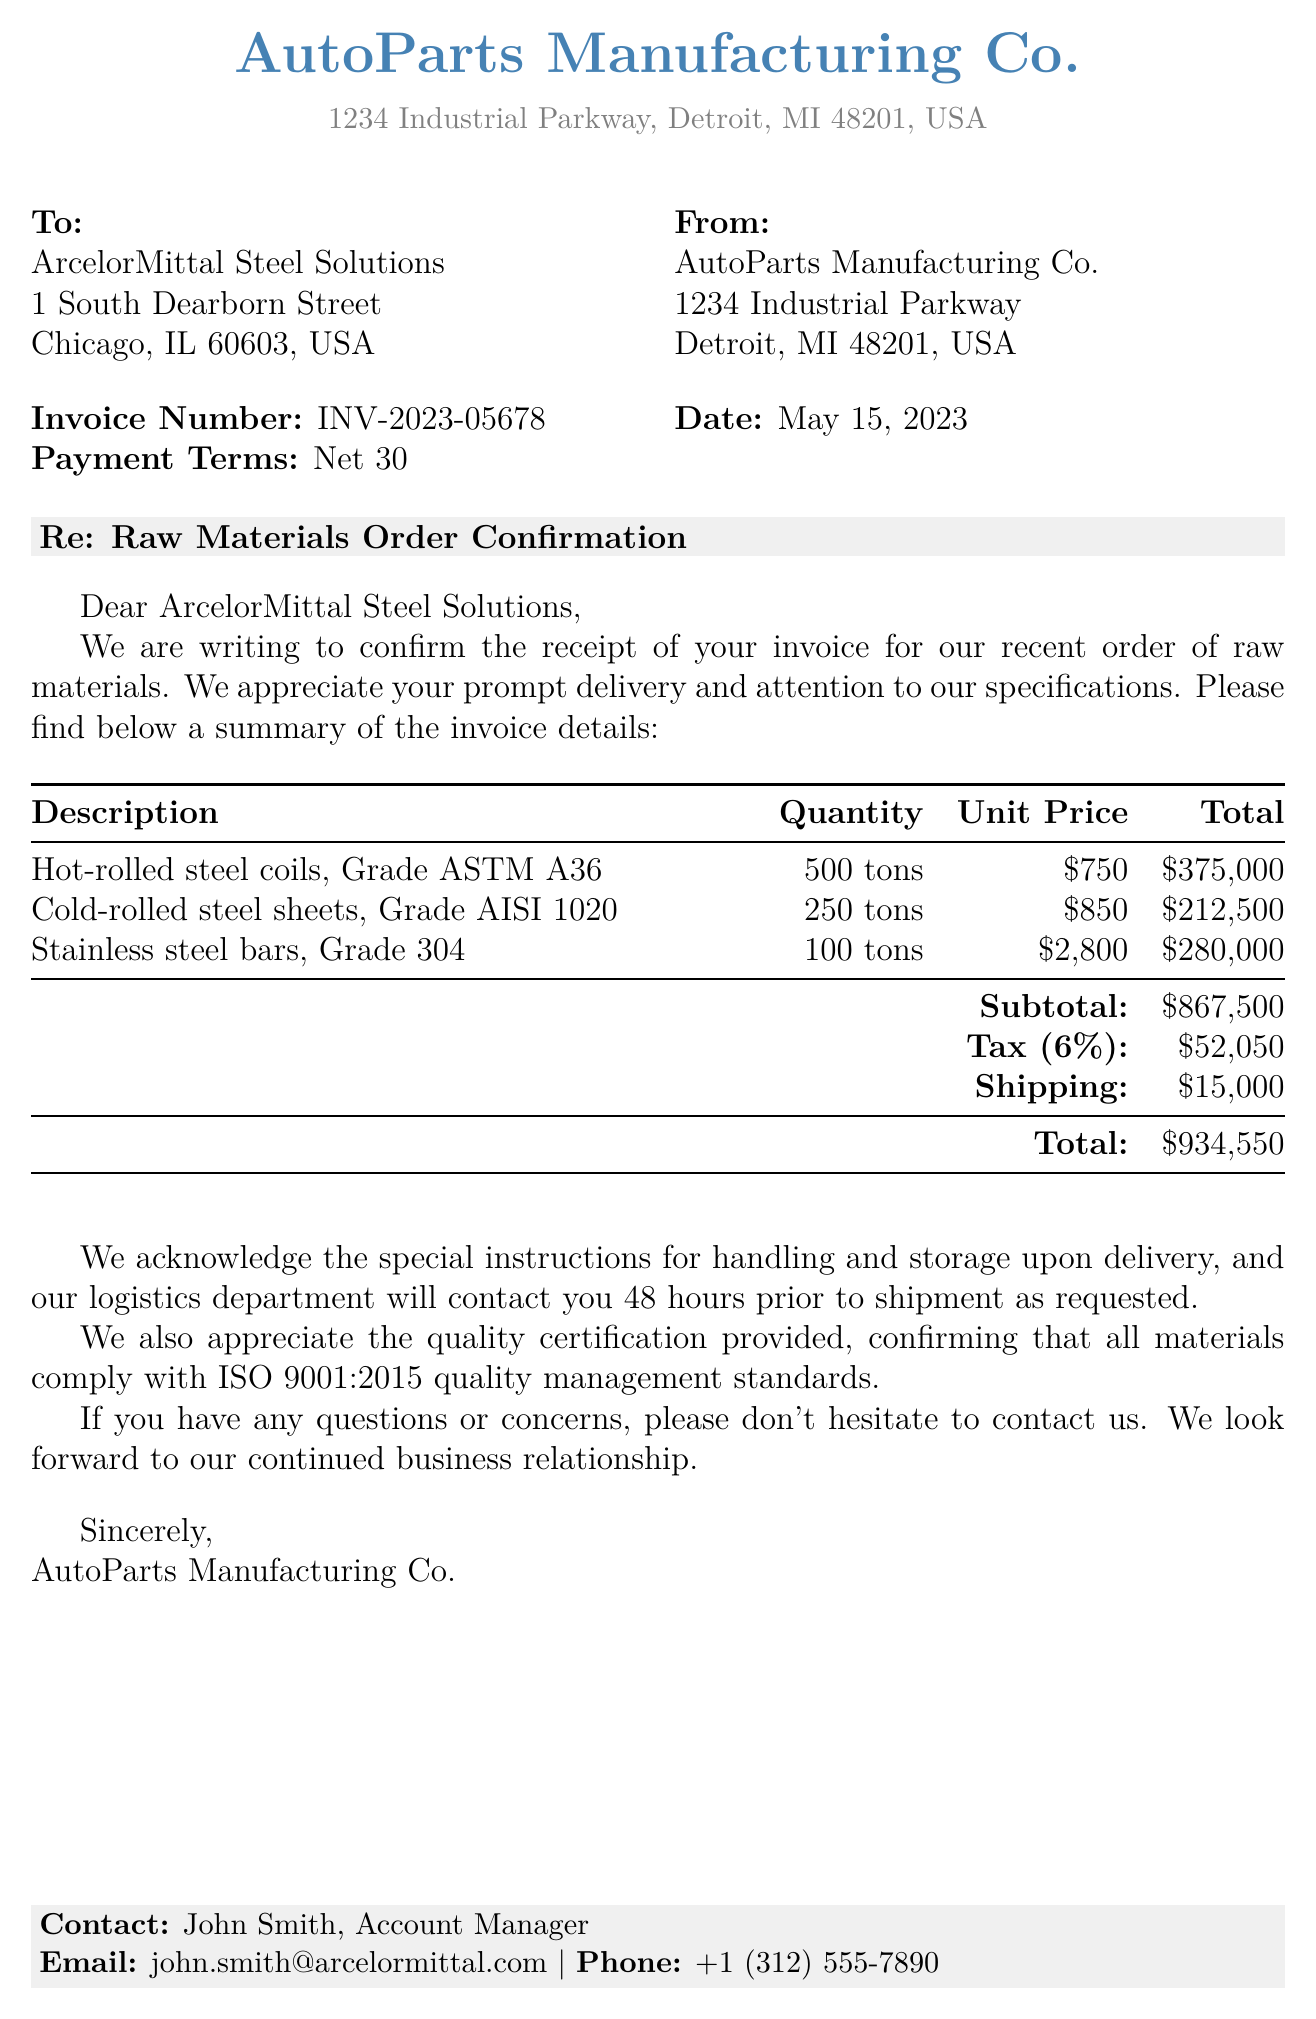What is the invoice number? The invoice number is explicitly stated in the document as a unique identifier for the transaction.
Answer: INV-2023-05678 Who is the supplier? The supplier's name appears at the beginning of the document, indicating who issued the invoice.
Answer: ArcelorMittal Steel Solutions What is the payment term? The payment term is a specified timeframe for when the payment is due, provided in the invoice details.
Answer: Net 30 How many tons of hot-rolled steel coils were ordered? The quantity of hot-rolled steel coils is listed under the line items, providing specific details about the order.
Answer: 500 tons What is the subtotal amount? The subtotal is the total before tax and shipping, aggregated from the line items.
Answer: $867,500 What is the tax rate applied? The tax rate is mentioned clearly in the invoice alongside the tax amount.
Answer: 6% What is the shipping cost? The shipping cost is separately stipulated in the invoice, indicating additional charges.
Answer: $15,000 What is the total amount due? The total amount is the final figure presented at the end of the invoice, including all charges.
Answer: $934,550 Who should be contacted for inquiries? The contact person is listed at the end of the document, specifying who to reach out to for further communication.
Answer: John Smith, Account Manager 